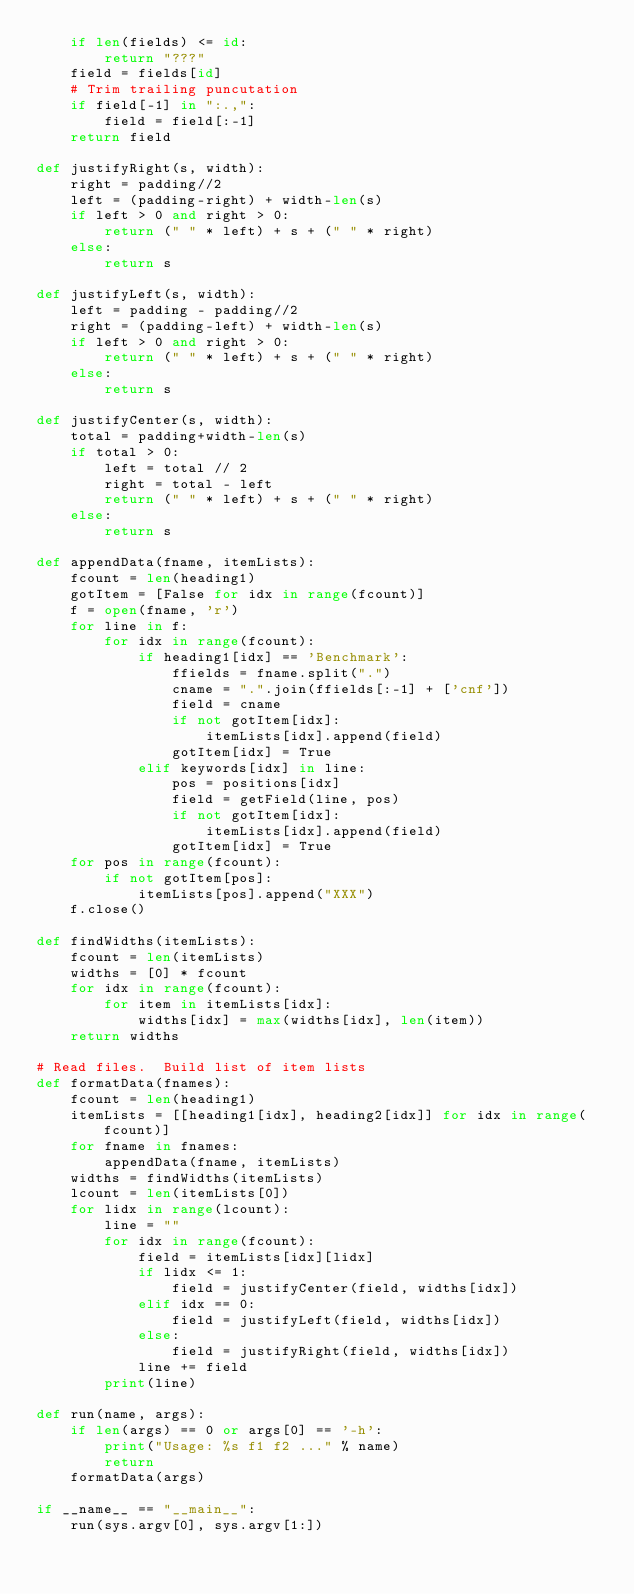<code> <loc_0><loc_0><loc_500><loc_500><_Python_>    if len(fields) <= id:
        return "???"
    field = fields[id]
    # Trim trailing puncutation
    if field[-1] in ":.,":
        field = field[:-1]
    return field

def justifyRight(s, width):
    right = padding//2
    left = (padding-right) + width-len(s)
    if left > 0 and right > 0:
        return (" " * left) + s + (" " * right)
    else:
        return s

def justifyLeft(s, width):
    left = padding - padding//2
    right = (padding-left) + width-len(s)
    if left > 0 and right > 0:
        return (" " * left) + s + (" " * right)
    else:
        return s

def justifyCenter(s, width):
    total = padding+width-len(s)
    if total > 0:
        left = total // 2
        right = total - left
        return (" " * left) + s + (" " * right)
    else:
        return s

def appendData(fname, itemLists):
    fcount = len(heading1)
    gotItem = [False for idx in range(fcount)]
    f = open(fname, 'r')
    for line in f:
        for idx in range(fcount):
            if heading1[idx] == 'Benchmark':
                ffields = fname.split(".")
                cname = ".".join(ffields[:-1] + ['cnf'])
                field = cname
                if not gotItem[idx]:
                    itemLists[idx].append(field)
                gotItem[idx] = True
            elif keywords[idx] in line:
                pos = positions[idx]
                field = getField(line, pos)
                if not gotItem[idx]:
                    itemLists[idx].append(field)
                gotItem[idx] = True
    for pos in range(fcount):
        if not gotItem[pos]:
            itemLists[pos].append("XXX")
    f.close()
        
def findWidths(itemLists):
    fcount = len(itemLists)
    widths = [0] * fcount
    for idx in range(fcount):
        for item in itemLists[idx]:
            widths[idx] = max(widths[idx], len(item))
    return widths

# Read files.  Build list of item lists
def formatData(fnames):
    fcount = len(heading1)
    itemLists = [[heading1[idx], heading2[idx]] for idx in range(fcount)]
    for fname in fnames:
        appendData(fname, itemLists)
    widths = findWidths(itemLists)
    lcount = len(itemLists[0])
    for lidx in range(lcount):
        line = ""
        for idx in range(fcount):
            field = itemLists[idx][lidx]
            if lidx <= 1:
                field = justifyCenter(field, widths[idx])
            elif idx == 0:
                field = justifyLeft(field, widths[idx])                
            else:
                field = justifyRight(field, widths[idx])
            line += field
        print(line)
    
def run(name, args):
    if len(args) == 0 or args[0] == '-h':
        print("Usage: %s f1 f2 ..." % name)
        return
    formatData(args)

if __name__ == "__main__":
    run(sys.argv[0], sys.argv[1:])

    
    
</code> 